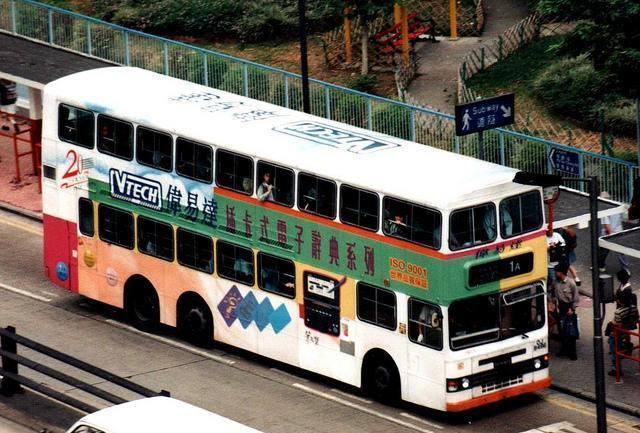How many birds are there?
Give a very brief answer. 0. 